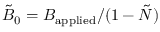<formula> <loc_0><loc_0><loc_500><loc_500>\tilde { B } _ { 0 } = B _ { a p p l i e d } / ( 1 - \tilde { N } )</formula> 